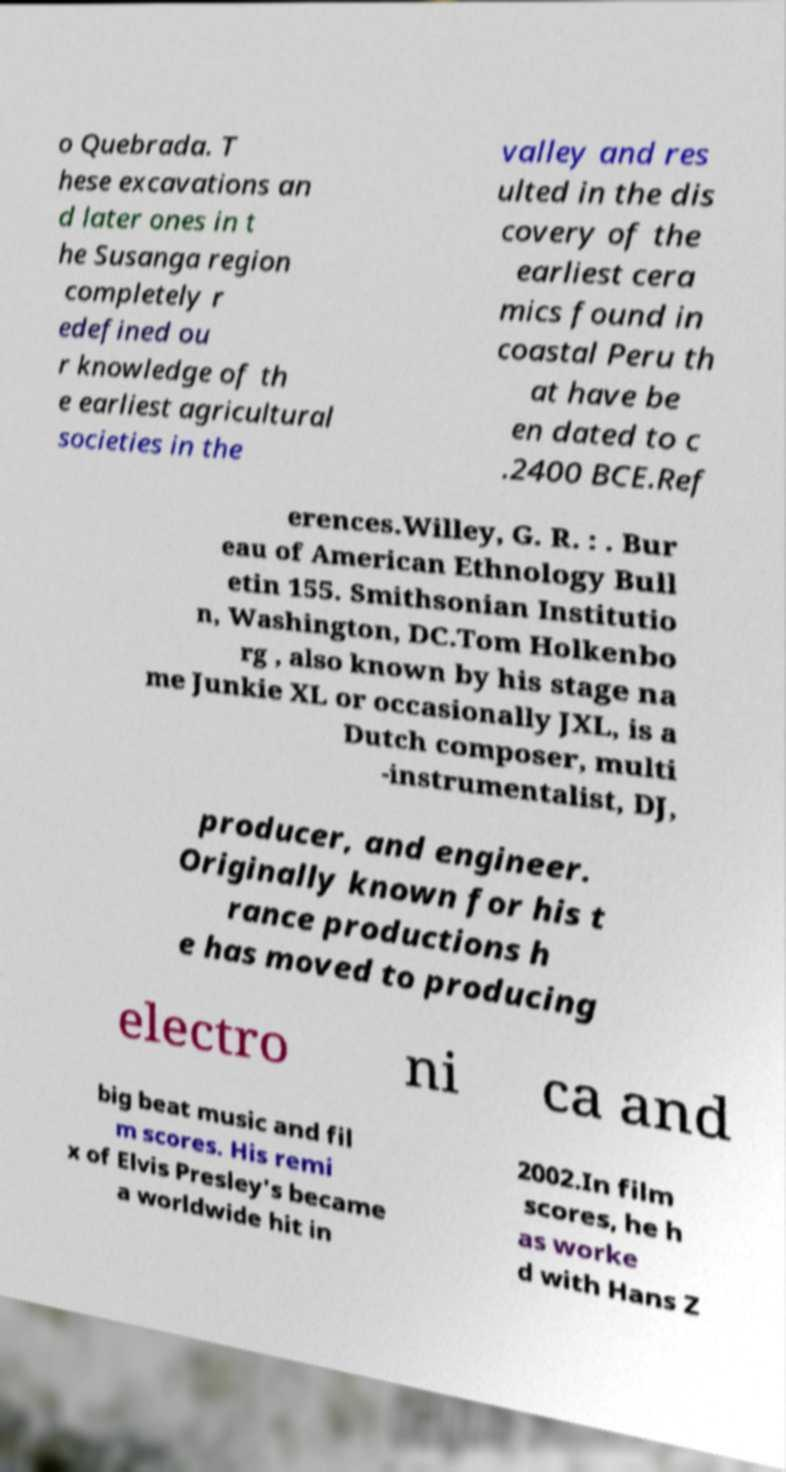Please identify and transcribe the text found in this image. o Quebrada. T hese excavations an d later ones in t he Susanga region completely r edefined ou r knowledge of th e earliest agricultural societies in the valley and res ulted in the dis covery of the earliest cera mics found in coastal Peru th at have be en dated to c .2400 BCE.Ref erences.Willey, G. R. : . Bur eau of American Ethnology Bull etin 155. Smithsonian Institutio n, Washington, DC.Tom Holkenbo rg , also known by his stage na me Junkie XL or occasionally JXL, is a Dutch composer, multi -instrumentalist, DJ, producer, and engineer. Originally known for his t rance productions h e has moved to producing electro ni ca and big beat music and fil m scores. His remi x of Elvis Presley's became a worldwide hit in 2002.In film scores, he h as worke d with Hans Z 